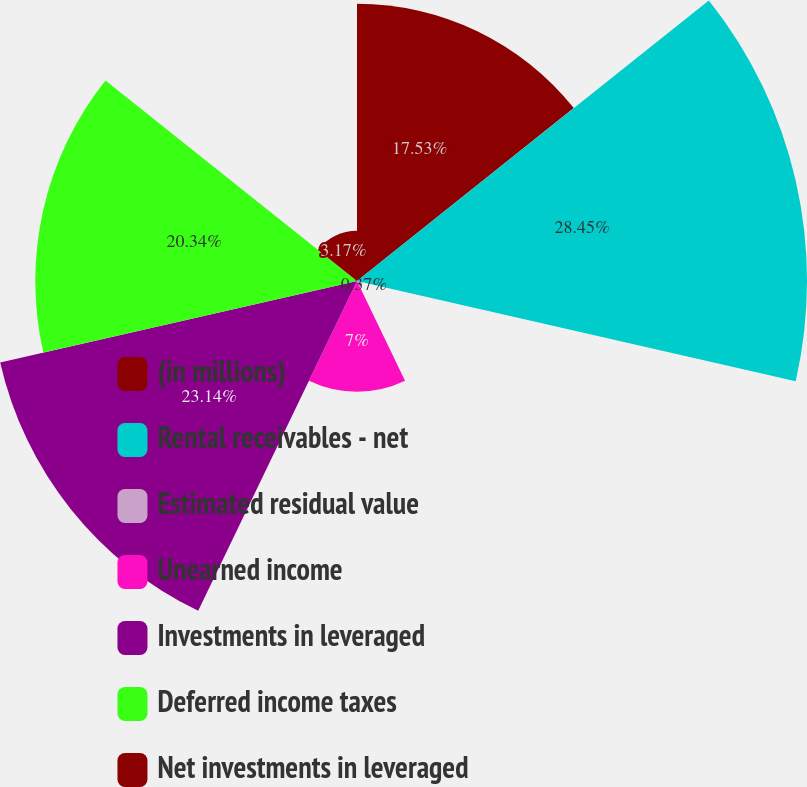Convert chart to OTSL. <chart><loc_0><loc_0><loc_500><loc_500><pie_chart><fcel>(in millions)<fcel>Rental receivables - net<fcel>Estimated residual value<fcel>Unearned income<fcel>Investments in leveraged<fcel>Deferred income taxes<fcel>Net investments in leveraged<nl><fcel>17.53%<fcel>28.45%<fcel>0.37%<fcel>7.0%<fcel>23.14%<fcel>20.34%<fcel>3.17%<nl></chart> 